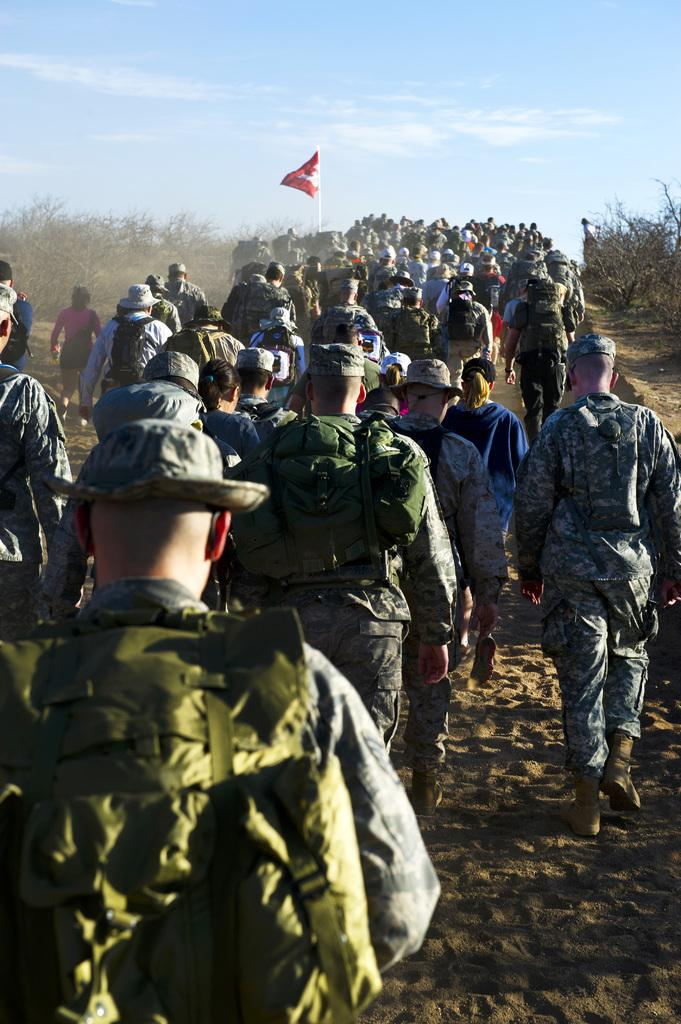What type of people can be seen in the image? There are army people in the image. What are the army people doing in the image? The army people are walking on the road. What can be seen in the background of the image? There is a flag and dry plants in the background of the image. What type of spot can be seen on the head of the army person in the image? There is no spot visible on the head of the army person in the image. Can you tell me if there is a sidewalk in the image? There is no mention of a sidewalk in the provided facts, so it cannot be determined from the image. 